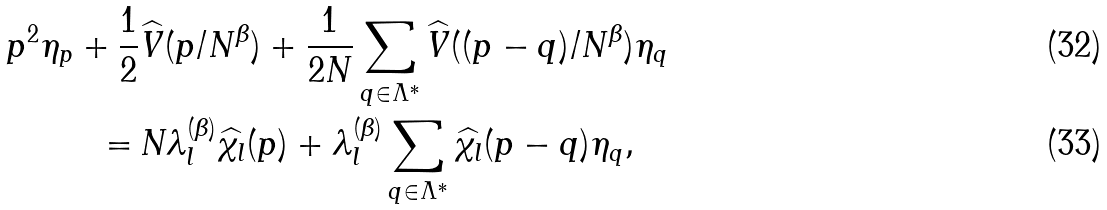<formula> <loc_0><loc_0><loc_500><loc_500>p ^ { 2 } \eta _ { p } + \frac { 1 } { 2 } & \widehat { V } ( p / N ^ { \beta } ) + \frac { 1 } { 2 N } \sum _ { q \in \Lambda ^ { * } } \widehat { V } ( ( p - q ) / N ^ { \beta } ) \eta _ { q } \\ = \, & N \lambda _ { l } ^ { ( \beta ) } \widehat { \chi _ { l } } ( p ) + \lambda _ { l } ^ { ( \beta ) } \sum _ { q \in \Lambda ^ { * } } \widehat { \chi _ { l } } ( p - q ) \eta _ { q } ,</formula> 